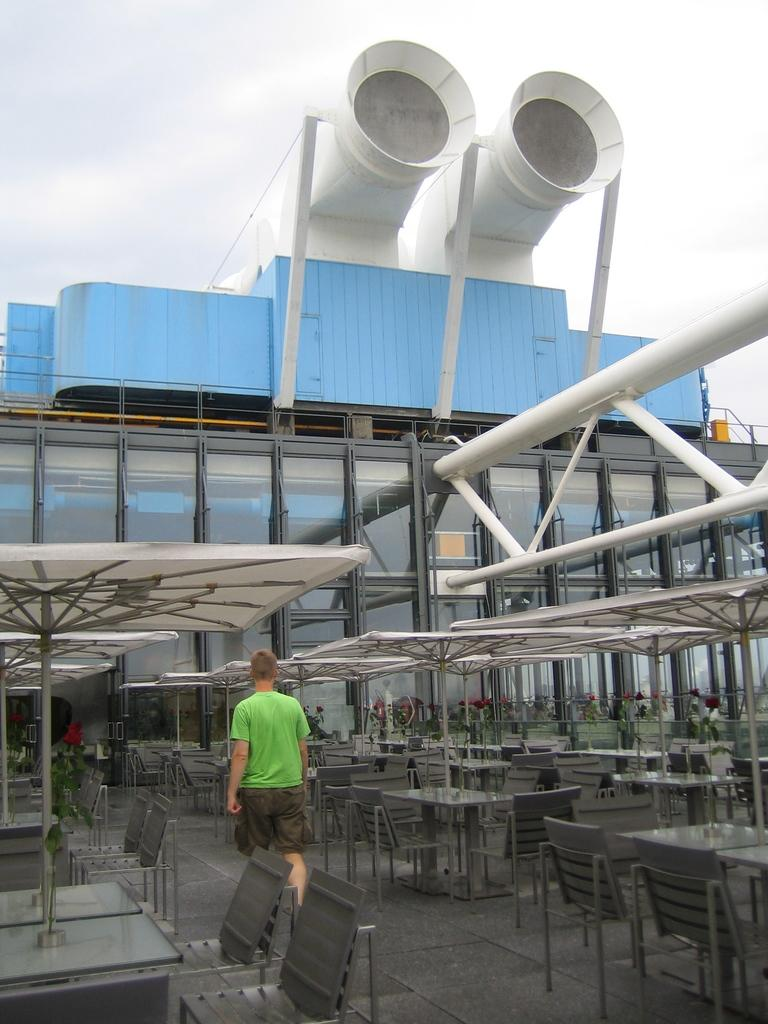What type of furniture can be seen in the image? There are chairs and tables in the image. What objects are present to provide shade or shelter? Umbrellas are present in the image for shade or shelter. What is the man in the image doing? A man is walking into a building in the image. What type of structure is visible in the image? There is a building in the image. What type of glove is the man wearing while walking into the building? There is no glove visible on the man in the image. What level of difficulty is the man experiencing while walking into the building? The image does not provide any information about the man's level of difficulty while walking into the building. 